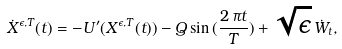<formula> <loc_0><loc_0><loc_500><loc_500>\dot { X } ^ { \epsilon , T } ( t ) = - U ^ { \prime } ( X ^ { \epsilon , T } ( t ) ) - Q \sin { ( \frac { 2 \, \pi t } { T } ) } + \sqrt { \epsilon } \, \dot { W } _ { t } ,</formula> 